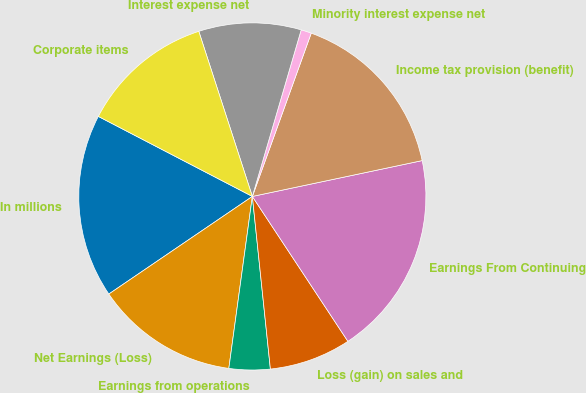Convert chart. <chart><loc_0><loc_0><loc_500><loc_500><pie_chart><fcel>In millions<fcel>Net Earnings (Loss)<fcel>Earnings from operations<fcel>Loss (gain) on sales and<fcel>Earnings From Continuing<fcel>Income tax provision (benefit)<fcel>Minority interest expense net<fcel>Interest expense net<fcel>Corporate items<nl><fcel>17.13%<fcel>13.33%<fcel>3.82%<fcel>7.62%<fcel>19.03%<fcel>16.18%<fcel>0.97%<fcel>9.53%<fcel>12.38%<nl></chart> 